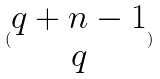<formula> <loc_0><loc_0><loc_500><loc_500>( \begin{matrix} q + n - 1 \\ q \end{matrix} )</formula> 